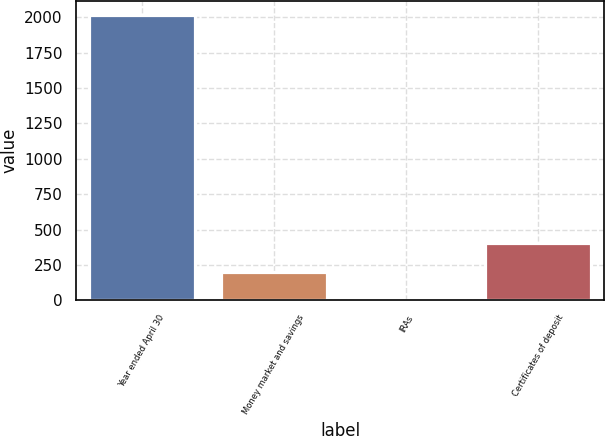Convert chart to OTSL. <chart><loc_0><loc_0><loc_500><loc_500><bar_chart><fcel>Year ended April 30<fcel>Money market and savings<fcel>IRAs<fcel>Certificates of deposit<nl><fcel>2015<fcel>201.64<fcel>0.15<fcel>403.12<nl></chart> 